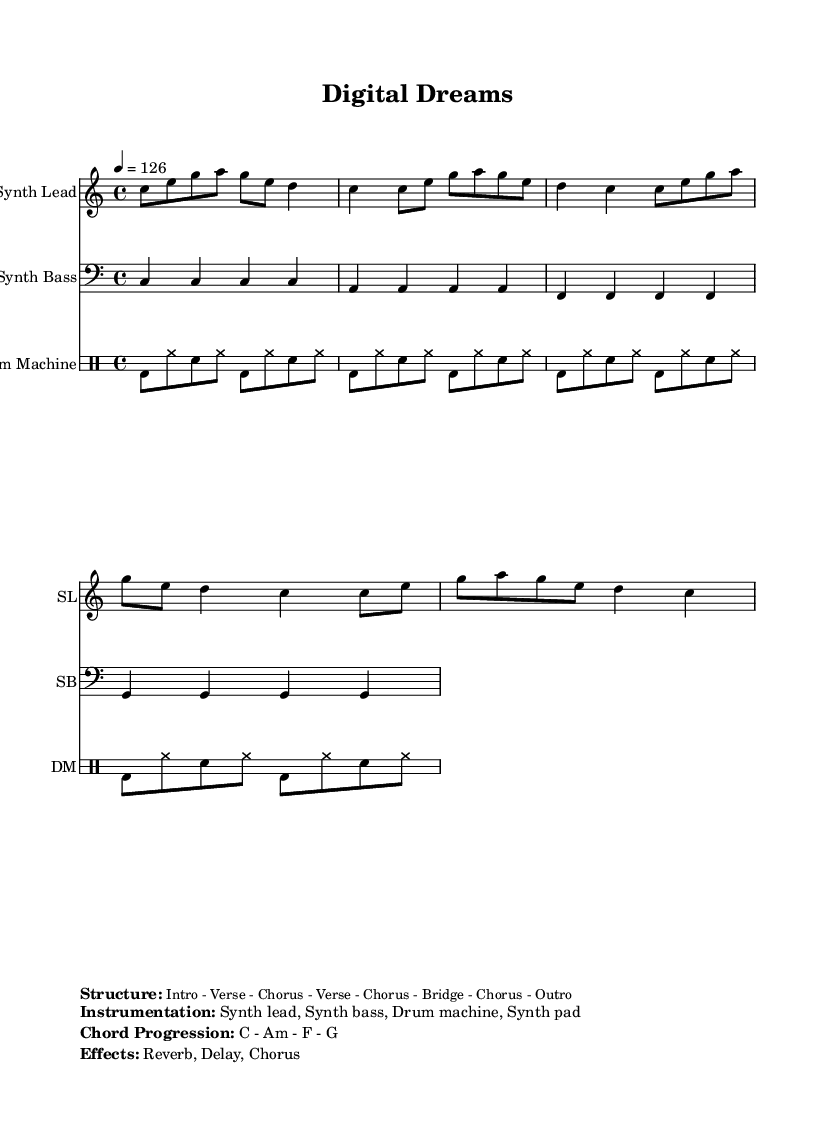What is the key signature of this music? The key signature is C major, which has no sharps or flats.
Answer: C major What is the time signature of this music? The time signature is located at the beginning of the score and is indicated as 4/4, meaning there are four beats in each measure.
Answer: 4/4 What is the tempo marking for this piece? The tempo is given as quarter note equals 126 beats per minute, indicating the speed at which the piece should be played.
Answer: 126 How many measures are in the repeating section of the synth lead? The synth lead is four measures long, as can be seen in the notation provided. Each set of notes is grouped into four distinct measures.
Answer: 4 measures What is the chord progression specified in the markup? The chord progression is mentioned in the instrumentation section of the markup, revealing the sequence of chords that accompany the melody.
Answer: C - Am - F - G Which instrument plays the bass line? The bass line is explicitly notated under the "Synth Bass" staff, indicating that this instrument is responsible for the lower harmonies.
Answer: Synth Bass What is the structure of the piece? The structure is detailed in the markup section, outlining the arrangement of sections and indicating how the music is organized throughout the piece.
Answer: Intro - Verse - Chorus - Verse - Chorus - Bridge - Chorus - Outro 